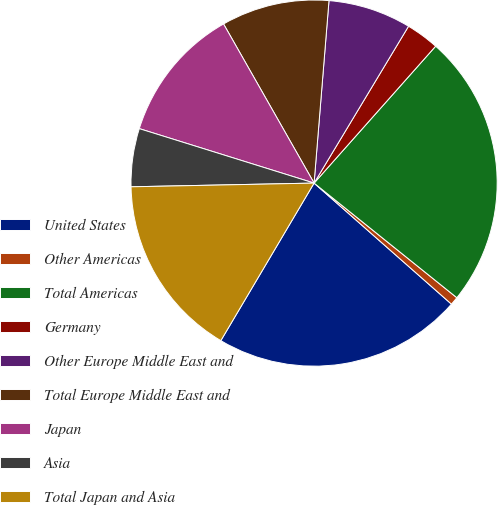Convert chart. <chart><loc_0><loc_0><loc_500><loc_500><pie_chart><fcel>United States<fcel>Other Americas<fcel>Total Americas<fcel>Germany<fcel>Other Europe Middle East and<fcel>Total Europe Middle East and<fcel>Japan<fcel>Asia<fcel>Total Japan and Asia<nl><fcel>22.01%<fcel>0.73%<fcel>24.21%<fcel>2.93%<fcel>7.33%<fcel>9.53%<fcel>11.96%<fcel>5.13%<fcel>16.17%<nl></chart> 